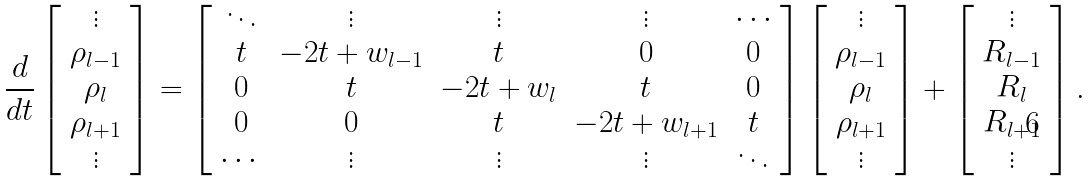Convert formula to latex. <formula><loc_0><loc_0><loc_500><loc_500>\frac { d } { d t } \left [ \begin{array} { c } \vdots \\ \rho _ { l - 1 } \\ \rho _ { l } \\ \rho _ { l + 1 } \\ \vdots \end{array} \right ] = \left [ \begin{array} { c c c c c } \ddots & \vdots & \vdots & \vdots & \cdots \\ t & - 2 t + w _ { l - 1 } & t & 0 & 0 \\ 0 & t & - 2 t + w _ { l } & t & 0 \\ 0 & 0 & t & - 2 t + w _ { l + 1 } & t \\ \cdots & \vdots & \vdots & \vdots & \ddots \\ \end{array} \right ] \left [ \begin{array} { c } \vdots \\ \rho _ { l - 1 } \\ \rho _ { l } \\ \rho _ { l + 1 } \\ \vdots \end{array} \right ] + \left [ \begin{array} { c } \vdots \\ R _ { l - 1 } \\ R _ { l } \\ R _ { l + 1 } \\ \vdots \end{array} \right ] .</formula> 